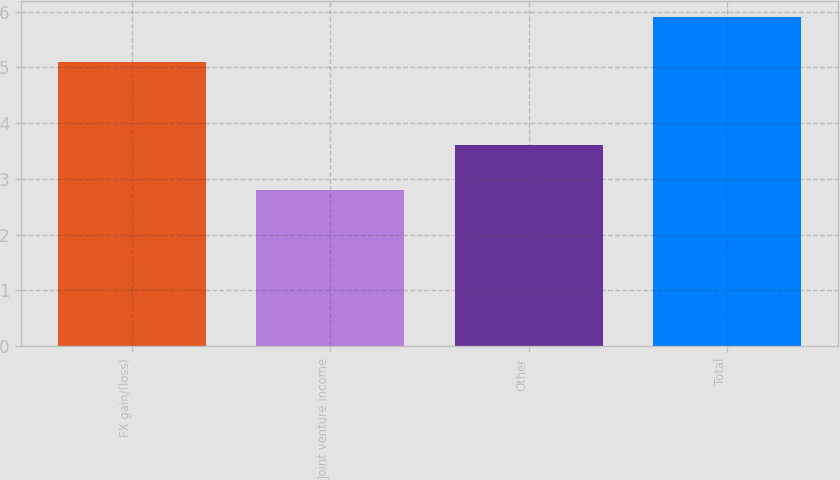Convert chart to OTSL. <chart><loc_0><loc_0><loc_500><loc_500><bar_chart><fcel>FX gain/(loss)<fcel>Joint venture income<fcel>Other<fcel>Total<nl><fcel>5.1<fcel>2.8<fcel>3.6<fcel>5.9<nl></chart> 